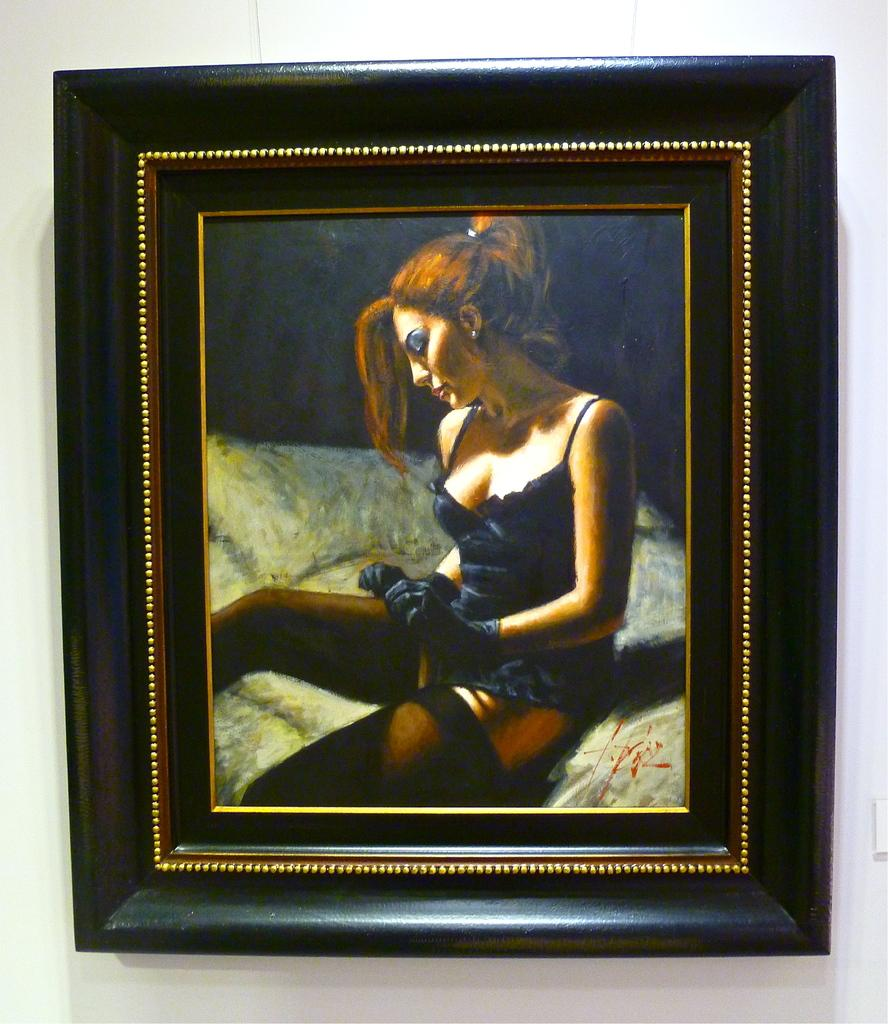What object can be seen in the image that is used for displaying photos? There is a photo frame in the image. Where is the photo frame located in the image? The photo frame is attached to the wall. What is the woman in the image doing? The woman is sitting on the bed. Is there any additional information about the photo frame? Yes, the photo frame has a signature on it. What type of root can be seen growing from the woman's wrist in the image? There is no root growing from the woman's wrist in the image. 